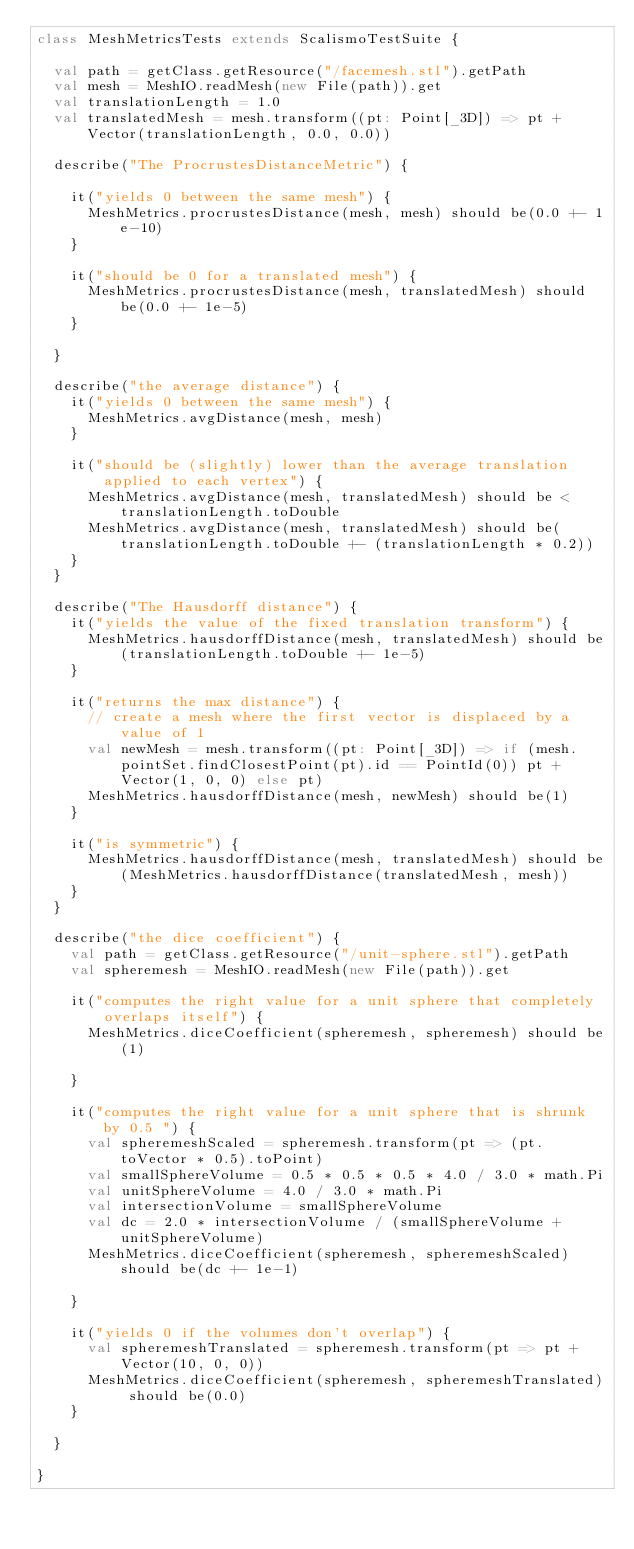Convert code to text. <code><loc_0><loc_0><loc_500><loc_500><_Scala_>class MeshMetricsTests extends ScalismoTestSuite {

  val path = getClass.getResource("/facemesh.stl").getPath
  val mesh = MeshIO.readMesh(new File(path)).get
  val translationLength = 1.0
  val translatedMesh = mesh.transform((pt: Point[_3D]) => pt + Vector(translationLength, 0.0, 0.0))

  describe("The ProcrustesDistanceMetric") {

    it("yields 0 between the same mesh") {
      MeshMetrics.procrustesDistance(mesh, mesh) should be(0.0 +- 1e-10)
    }

    it("should be 0 for a translated mesh") {
      MeshMetrics.procrustesDistance(mesh, translatedMesh) should be(0.0 +- 1e-5)
    }

  }

  describe("the average distance") {
    it("yields 0 between the same mesh") {
      MeshMetrics.avgDistance(mesh, mesh)
    }

    it("should be (slightly) lower than the average translation applied to each vertex") {
      MeshMetrics.avgDistance(mesh, translatedMesh) should be < translationLength.toDouble
      MeshMetrics.avgDistance(mesh, translatedMesh) should be(translationLength.toDouble +- (translationLength * 0.2))
    }
  }

  describe("The Hausdorff distance") {
    it("yields the value of the fixed translation transform") {
      MeshMetrics.hausdorffDistance(mesh, translatedMesh) should be(translationLength.toDouble +- 1e-5)
    }

    it("returns the max distance") {
      // create a mesh where the first vector is displaced by a value of 1
      val newMesh = mesh.transform((pt: Point[_3D]) => if (mesh.pointSet.findClosestPoint(pt).id == PointId(0)) pt + Vector(1, 0, 0) else pt)
      MeshMetrics.hausdorffDistance(mesh, newMesh) should be(1)
    }

    it("is symmetric") {
      MeshMetrics.hausdorffDistance(mesh, translatedMesh) should be(MeshMetrics.hausdorffDistance(translatedMesh, mesh))
    }
  }

  describe("the dice coefficient") {
    val path = getClass.getResource("/unit-sphere.stl").getPath
    val spheremesh = MeshIO.readMesh(new File(path)).get

    it("computes the right value for a unit sphere that completely overlaps itself") {
      MeshMetrics.diceCoefficient(spheremesh, spheremesh) should be(1)

    }

    it("computes the right value for a unit sphere that is shrunk by 0.5 ") {
      val spheremeshScaled = spheremesh.transform(pt => (pt.toVector * 0.5).toPoint)
      val smallSphereVolume = 0.5 * 0.5 * 0.5 * 4.0 / 3.0 * math.Pi
      val unitSphereVolume = 4.0 / 3.0 * math.Pi
      val intersectionVolume = smallSphereVolume
      val dc = 2.0 * intersectionVolume / (smallSphereVolume + unitSphereVolume)
      MeshMetrics.diceCoefficient(spheremesh, spheremeshScaled) should be(dc +- 1e-1)

    }

    it("yields 0 if the volumes don't overlap") {
      val spheremeshTranslated = spheremesh.transform(pt => pt + Vector(10, 0, 0))
      MeshMetrics.diceCoefficient(spheremesh, spheremeshTranslated) should be(0.0)
    }

  }

}

</code> 